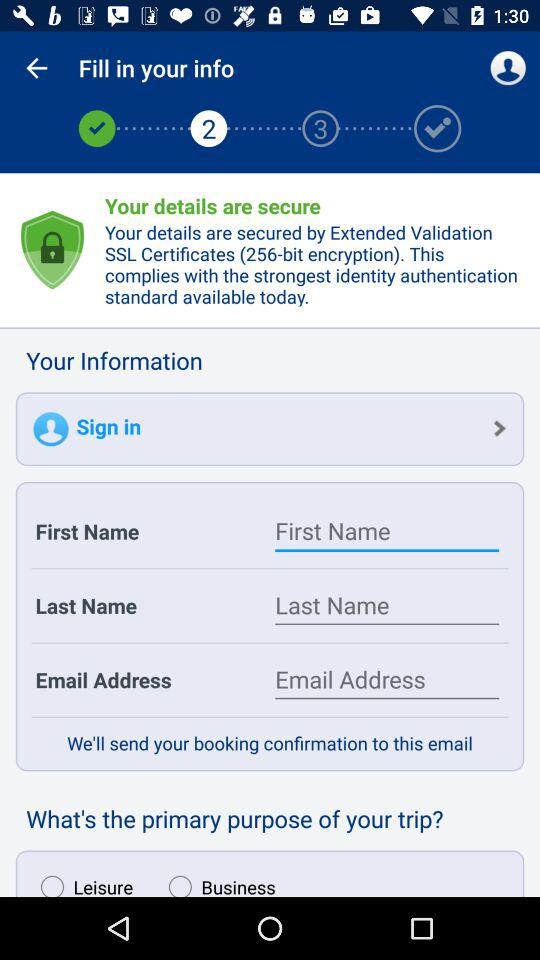At which step number am I? You are at step number 2. 